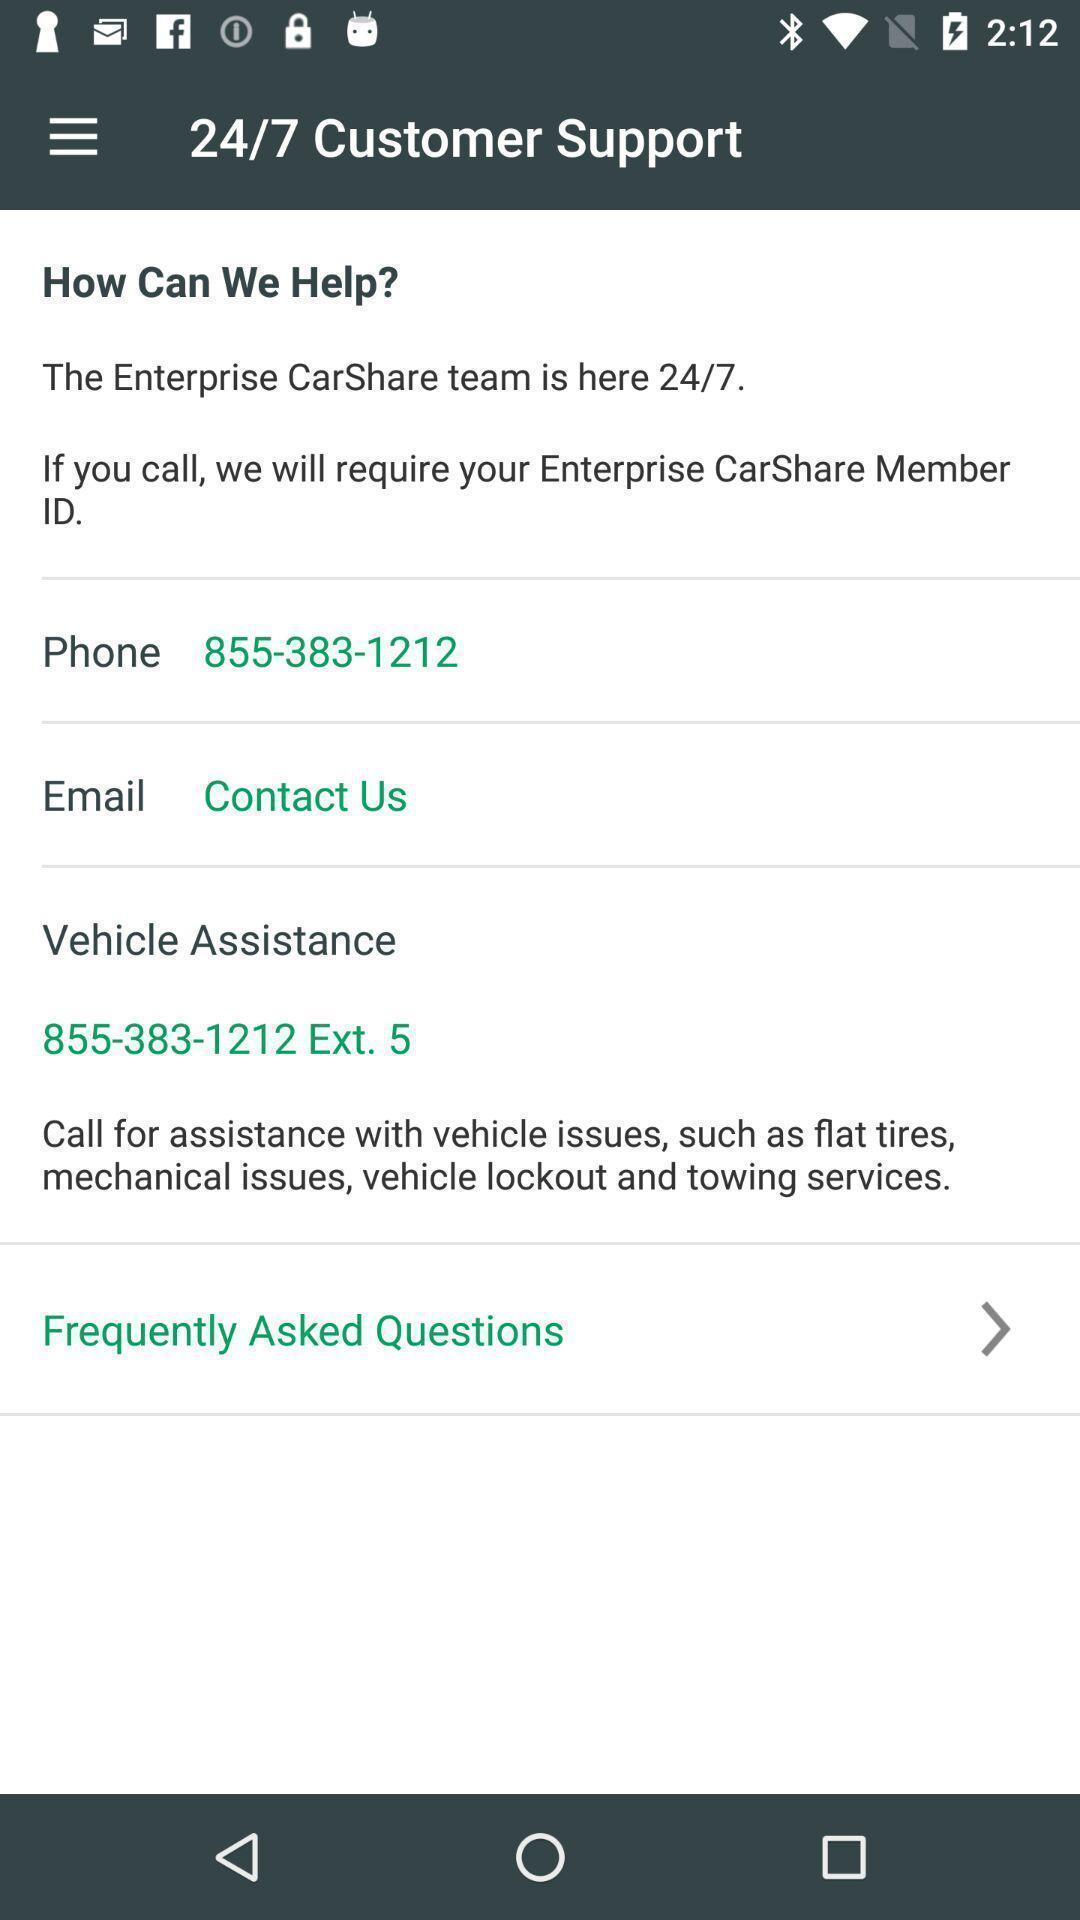Explain the elements present in this screenshot. Page showing information. 